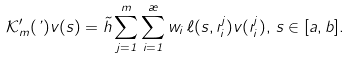Convert formula to latex. <formula><loc_0><loc_0><loc_500><loc_500>\mathcal { K } _ { m } ^ { \prime } ( \varphi ) v ( s ) = \tilde { h } \sum _ { j = 1 } ^ { m } \sum _ { i = 1 } ^ { \rho } w _ { i } \, \ell ( s , \zeta _ { i } ^ { j } ) v ( \zeta _ { i } ^ { j } ) , \, s \in [ a , b ] .</formula> 